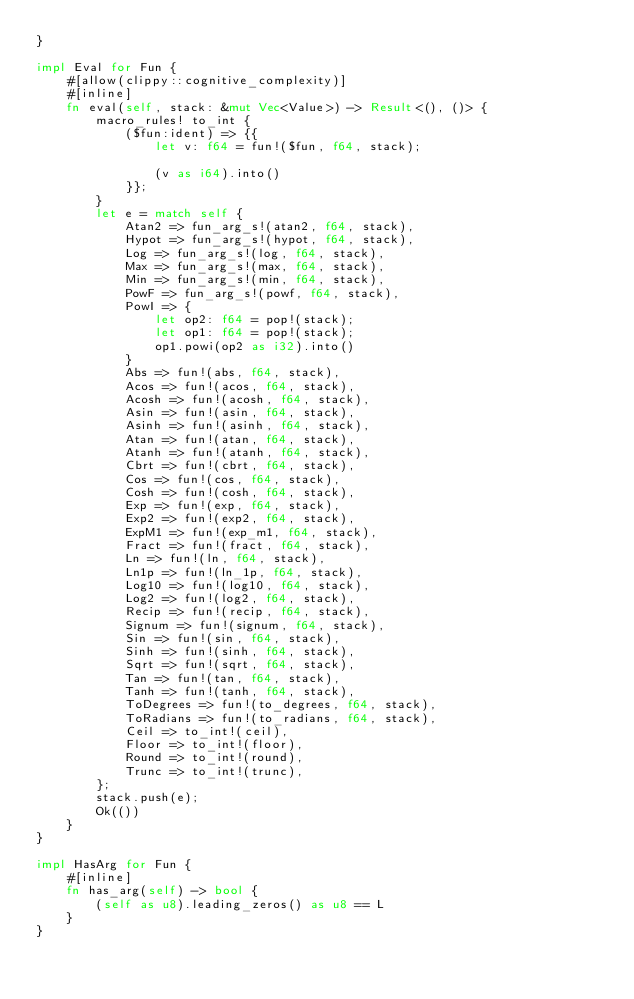<code> <loc_0><loc_0><loc_500><loc_500><_Rust_>}

impl Eval for Fun {
    #[allow(clippy::cognitive_complexity)]
    #[inline]
    fn eval(self, stack: &mut Vec<Value>) -> Result<(), ()> {
        macro_rules! to_int {
            ($fun:ident) => {{
                let v: f64 = fun!($fun, f64, stack);

                (v as i64).into()
            }};
        }
        let e = match self {
            Atan2 => fun_arg_s!(atan2, f64, stack),
            Hypot => fun_arg_s!(hypot, f64, stack),
            Log => fun_arg_s!(log, f64, stack),
            Max => fun_arg_s!(max, f64, stack),
            Min => fun_arg_s!(min, f64, stack),
            PowF => fun_arg_s!(powf, f64, stack),
            PowI => {
                let op2: f64 = pop!(stack);
                let op1: f64 = pop!(stack);
                op1.powi(op2 as i32).into()
            }
            Abs => fun!(abs, f64, stack),
            Acos => fun!(acos, f64, stack),
            Acosh => fun!(acosh, f64, stack),
            Asin => fun!(asin, f64, stack),
            Asinh => fun!(asinh, f64, stack),
            Atan => fun!(atan, f64, stack),
            Atanh => fun!(atanh, f64, stack),
            Cbrt => fun!(cbrt, f64, stack),
            Cos => fun!(cos, f64, stack),
            Cosh => fun!(cosh, f64, stack),
            Exp => fun!(exp, f64, stack),
            Exp2 => fun!(exp2, f64, stack),
            ExpM1 => fun!(exp_m1, f64, stack),
            Fract => fun!(fract, f64, stack),
            Ln => fun!(ln, f64, stack),
            Ln1p => fun!(ln_1p, f64, stack),
            Log10 => fun!(log10, f64, stack),
            Log2 => fun!(log2, f64, stack),
            Recip => fun!(recip, f64, stack),
            Signum => fun!(signum, f64, stack),
            Sin => fun!(sin, f64, stack),
            Sinh => fun!(sinh, f64, stack),
            Sqrt => fun!(sqrt, f64, stack),
            Tan => fun!(tan, f64, stack),
            Tanh => fun!(tanh, f64, stack),
            ToDegrees => fun!(to_degrees, f64, stack),
            ToRadians => fun!(to_radians, f64, stack),
            Ceil => to_int!(ceil),
            Floor => to_int!(floor),
            Round => to_int!(round),
            Trunc => to_int!(trunc),
        };
        stack.push(e);
        Ok(())
    }
}

impl HasArg for Fun {
    #[inline]
    fn has_arg(self) -> bool {
        (self as u8).leading_zeros() as u8 == L
    }
}
</code> 